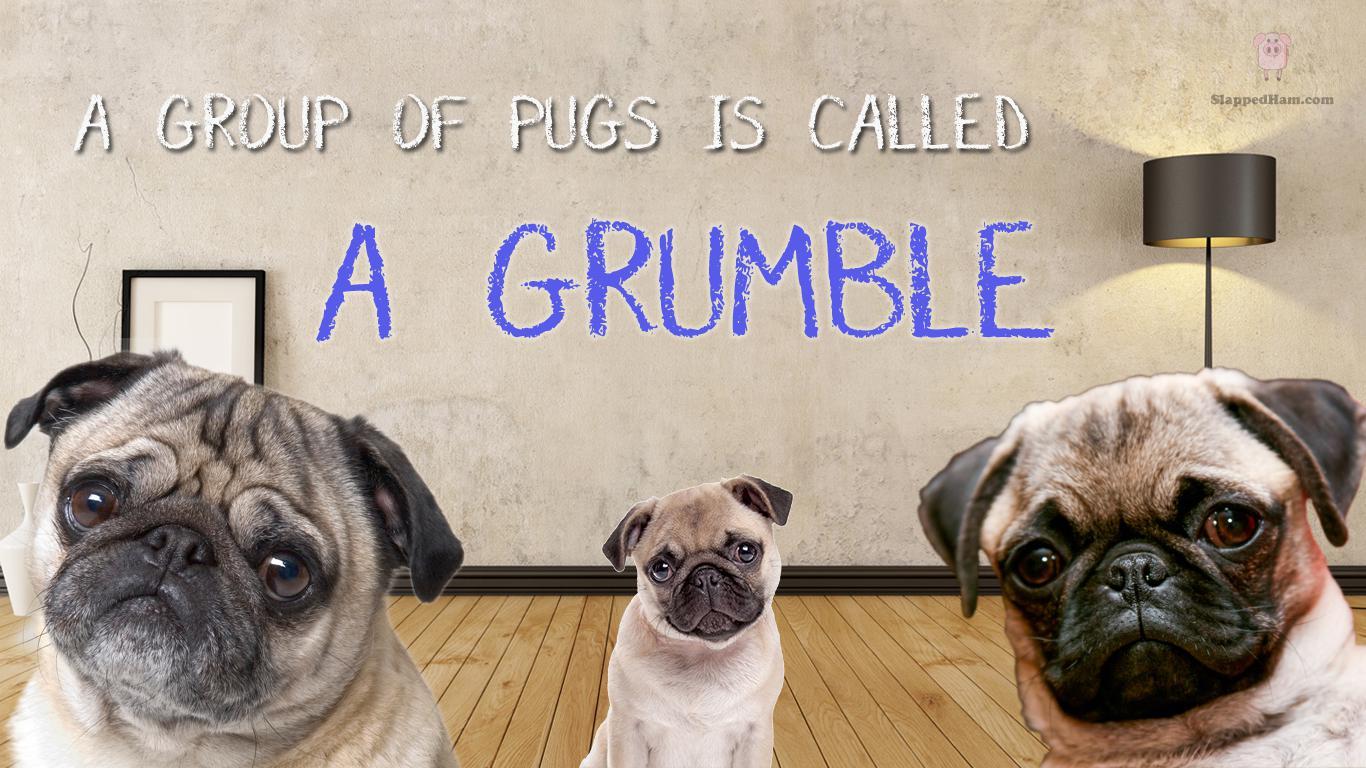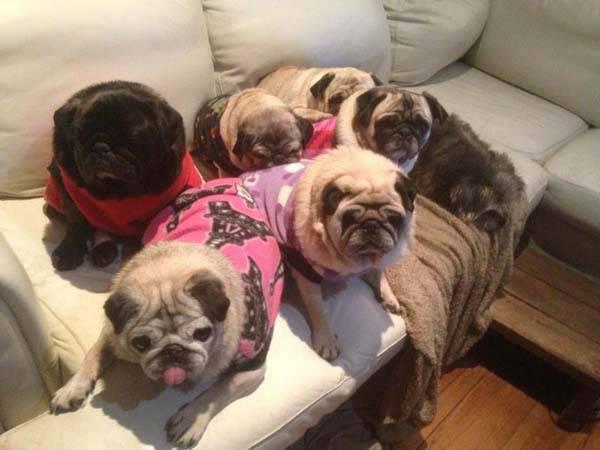The first image is the image on the left, the second image is the image on the right. Given the left and right images, does the statement "One picture has exactly three pugs." hold true? Answer yes or no. Yes. 